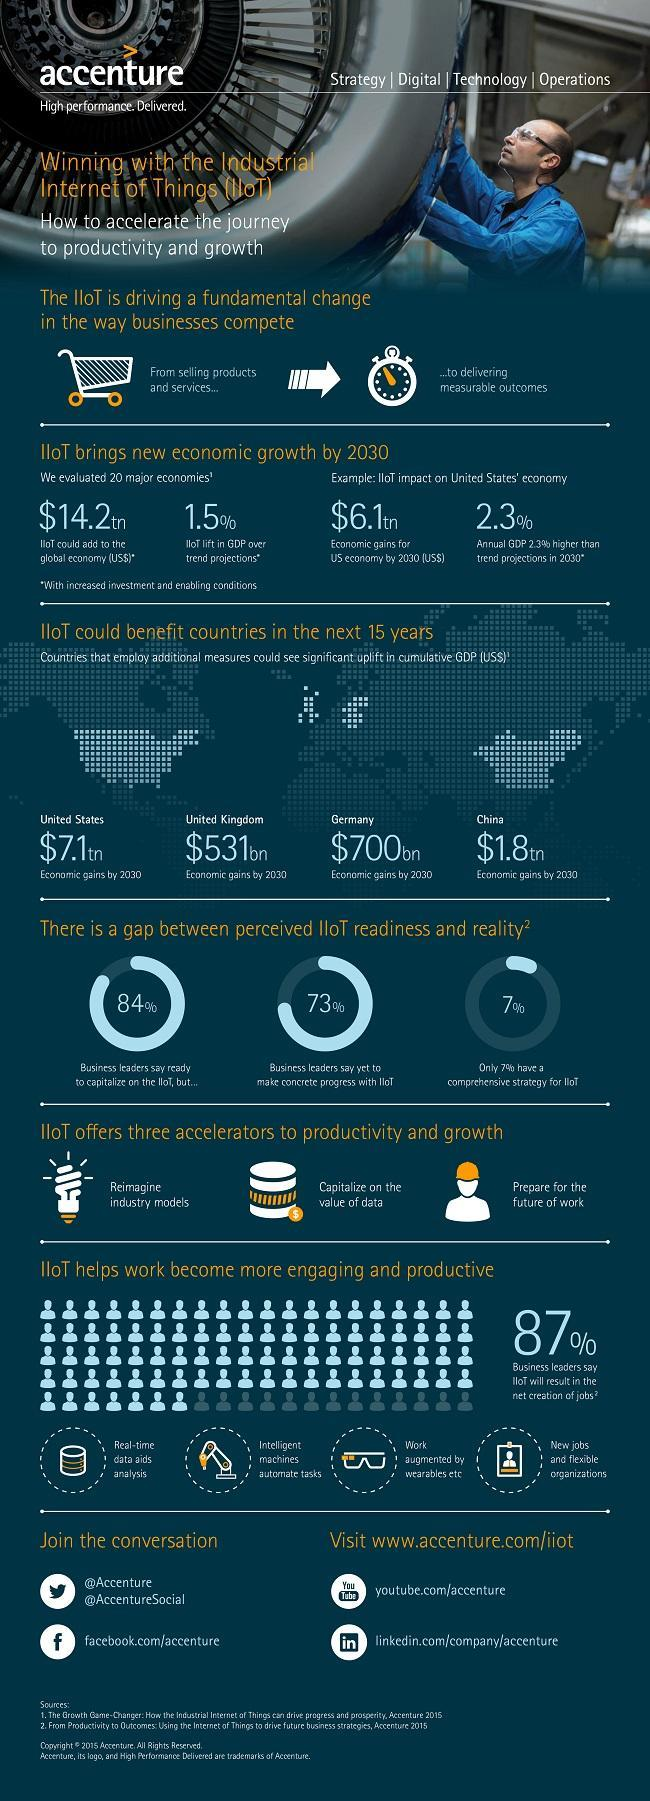What could be the economic gains for United Kingdom by 2030?
Answer the question with a short phrase. $531bn What will help to capitalize on the value of data? IIoT What is the amount IIoT that could add to the global economy by 2030? $14.2tn How many of the business leaders say yet to make concrete progress with IIoT? 73% How much will be the economic gains for US economy by 2030 as an impact of IIoT? $6.1tn How many of the business leaders have a comprehensive strategy for IIoT? 7% What could be the economic gains for China by 2030? $1.8tn How many of the business leaders say ready to capitalize on IIoT? 84% What could be the economic gains for Germany by 2030? $700bn What is the expected IIoT lift in GDP by 2030? 1.5% 